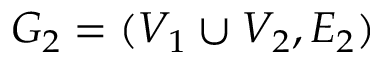Convert formula to latex. <formula><loc_0><loc_0><loc_500><loc_500>G _ { 2 } = ( V _ { 1 } \cup V _ { 2 } , E _ { 2 } )</formula> 